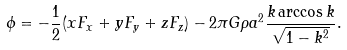<formula> <loc_0><loc_0><loc_500><loc_500>\phi = - \frac { 1 } { 2 } ( x F _ { x } + y F _ { y } + z F _ { z } ) - 2 \pi G \rho a ^ { 2 } \frac { k \arccos { k } } { \sqrt { 1 - k ^ { 2 } } } .</formula> 